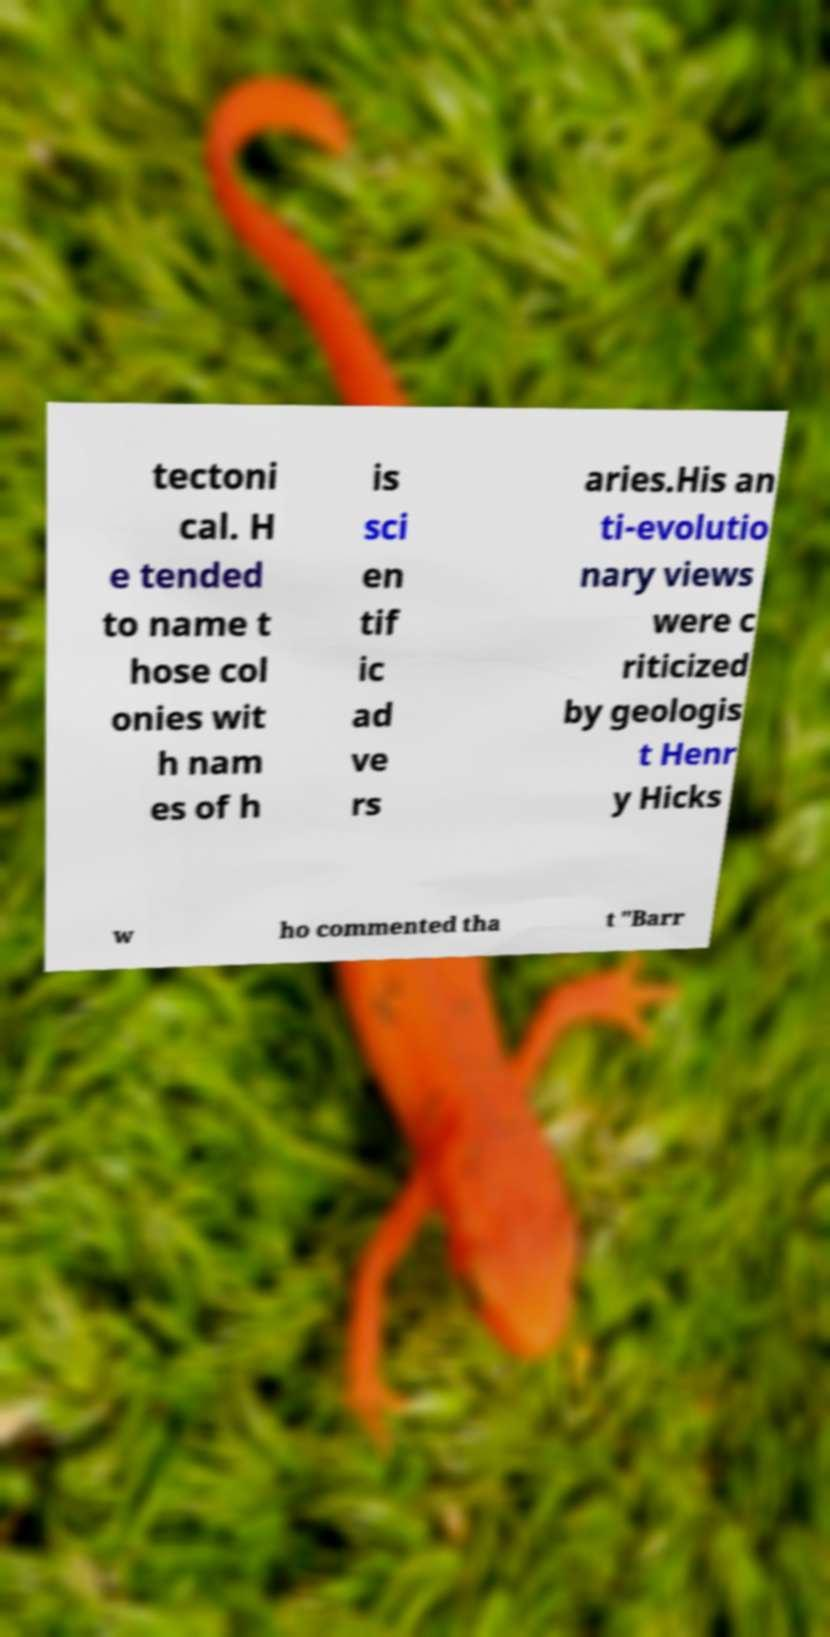What messages or text are displayed in this image? I need them in a readable, typed format. tectoni cal. H e tended to name t hose col onies wit h nam es of h is sci en tif ic ad ve rs aries.His an ti-evolutio nary views were c riticized by geologis t Henr y Hicks w ho commented tha t "Barr 